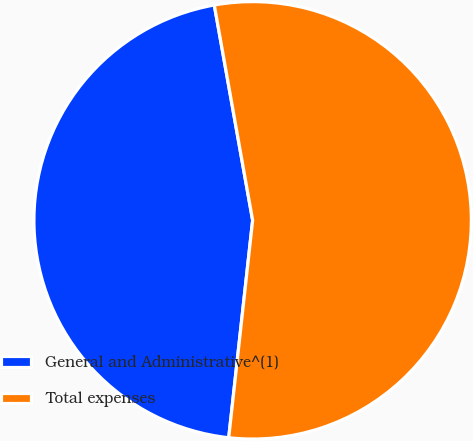Convert chart to OTSL. <chart><loc_0><loc_0><loc_500><loc_500><pie_chart><fcel>General and Administrative^(1)<fcel>Total expenses<nl><fcel>45.45%<fcel>54.55%<nl></chart> 